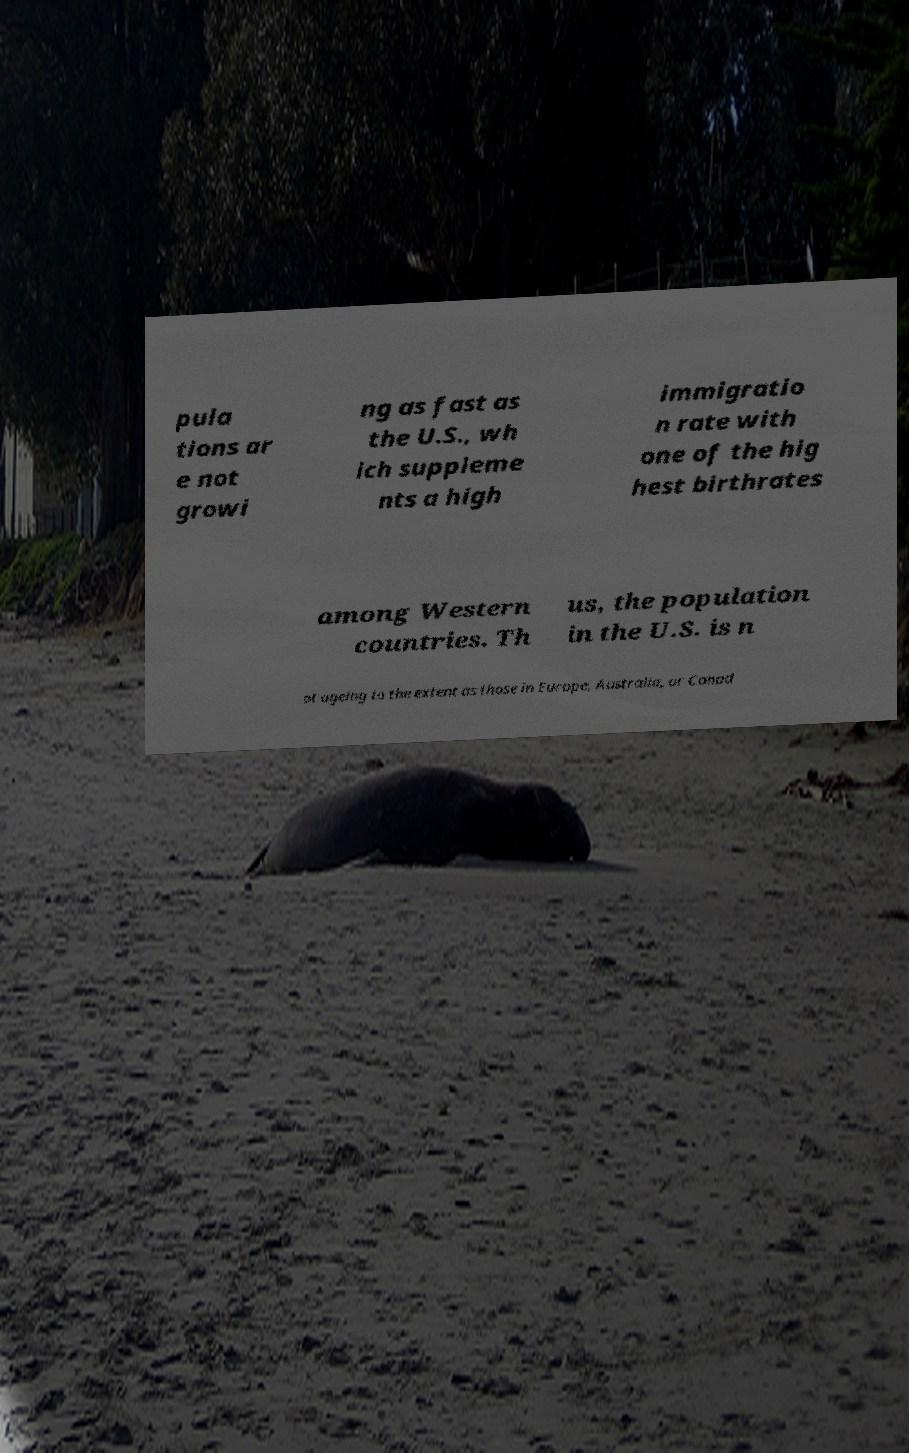Please read and relay the text visible in this image. What does it say? pula tions ar e not growi ng as fast as the U.S., wh ich suppleme nts a high immigratio n rate with one of the hig hest birthrates among Western countries. Th us, the population in the U.S. is n ot ageing to the extent as those in Europe, Australia, or Canad 